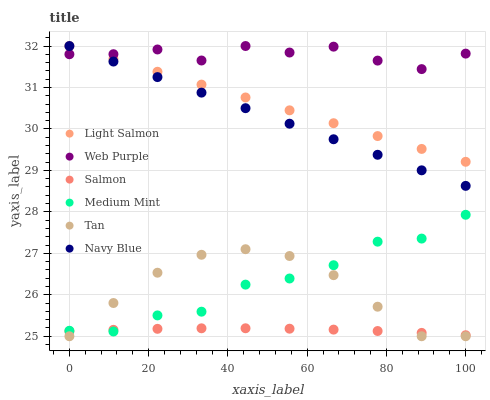Does Salmon have the minimum area under the curve?
Answer yes or no. Yes. Does Web Purple have the maximum area under the curve?
Answer yes or no. Yes. Does Light Salmon have the minimum area under the curve?
Answer yes or no. No. Does Light Salmon have the maximum area under the curve?
Answer yes or no. No. Is Light Salmon the smoothest?
Answer yes or no. Yes. Is Medium Mint the roughest?
Answer yes or no. Yes. Is Navy Blue the smoothest?
Answer yes or no. No. Is Navy Blue the roughest?
Answer yes or no. No. Does Tan have the lowest value?
Answer yes or no. Yes. Does Light Salmon have the lowest value?
Answer yes or no. No. Does Web Purple have the highest value?
Answer yes or no. Yes. Does Salmon have the highest value?
Answer yes or no. No. Is Tan less than Web Purple?
Answer yes or no. Yes. Is Light Salmon greater than Medium Mint?
Answer yes or no. Yes. Does Web Purple intersect Light Salmon?
Answer yes or no. Yes. Is Web Purple less than Light Salmon?
Answer yes or no. No. Is Web Purple greater than Light Salmon?
Answer yes or no. No. Does Tan intersect Web Purple?
Answer yes or no. No. 